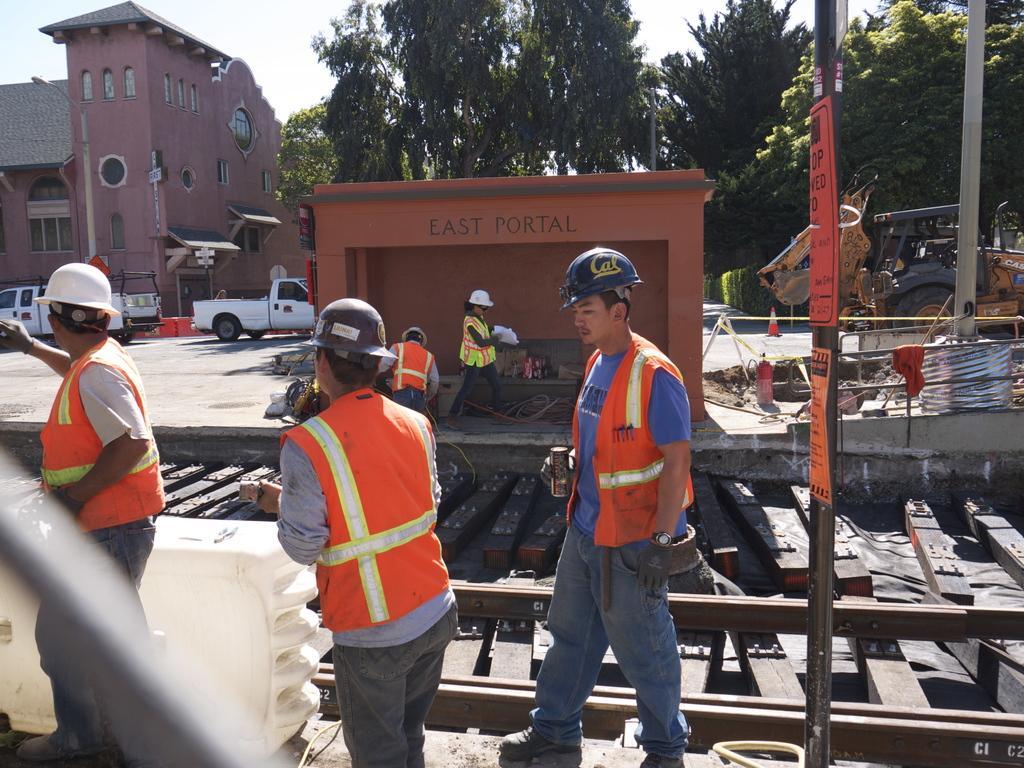Describe this image in one or two sentences. In this image I can see there are few people walking, there is a railway track being constructed and there are trees in the backdrop, there is a building on the left side and the sky is clear. 